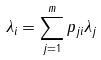<formula> <loc_0><loc_0><loc_500><loc_500>\lambda _ { i } = \sum _ { j = 1 } ^ { m } p _ { j i } \lambda _ { j }</formula> 